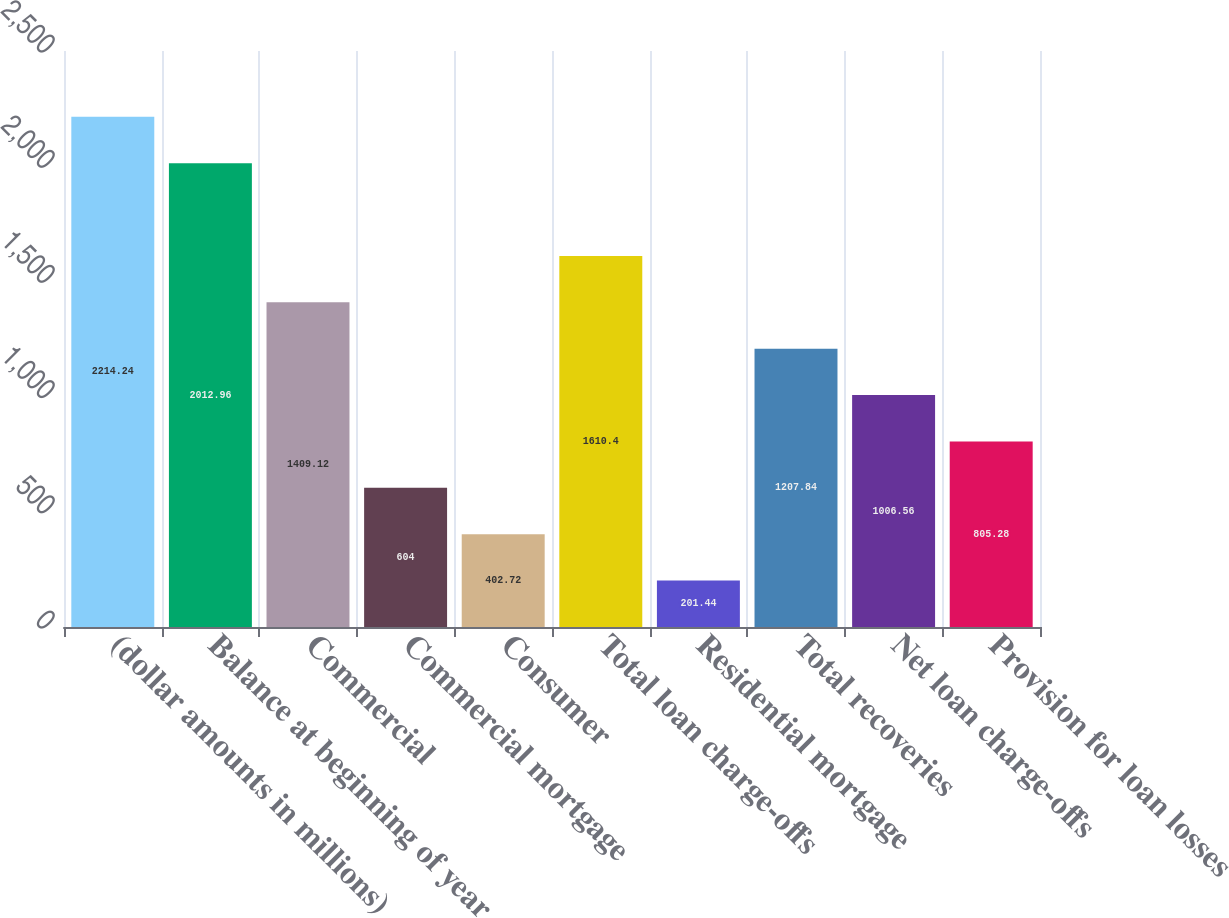Convert chart to OTSL. <chart><loc_0><loc_0><loc_500><loc_500><bar_chart><fcel>(dollar amounts in millions)<fcel>Balance at beginning of year<fcel>Commercial<fcel>Commercial mortgage<fcel>Consumer<fcel>Total loan charge-offs<fcel>Residential mortgage<fcel>Total recoveries<fcel>Net loan charge-offs<fcel>Provision for loan losses<nl><fcel>2214.24<fcel>2012.96<fcel>1409.12<fcel>604<fcel>402.72<fcel>1610.4<fcel>201.44<fcel>1207.84<fcel>1006.56<fcel>805.28<nl></chart> 